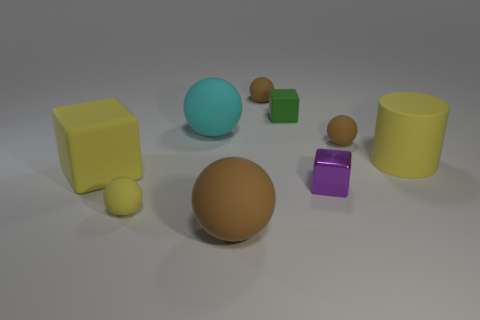Are there any other cyan balls made of the same material as the big cyan sphere?
Provide a short and direct response. No. What material is the big thing that is to the left of the big cyan sphere?
Ensure brevity in your answer.  Rubber. Does the small sphere in front of the large yellow matte cylinder have the same color as the cube behind the big cyan sphere?
Keep it short and to the point. No. The cube that is the same size as the cylinder is what color?
Your answer should be very brief. Yellow. How many other things are there of the same shape as the purple object?
Provide a succinct answer. 2. What size is the yellow rubber object on the right side of the big cyan rubber thing?
Ensure brevity in your answer.  Large. There is a small rubber thing on the left side of the big cyan rubber thing; what number of tiny yellow spheres are behind it?
Your answer should be compact. 0. How many other objects are there of the same size as the purple metal block?
Offer a terse response. 4. Is the color of the tiny matte block the same as the big cylinder?
Offer a very short reply. No. There is a yellow object that is right of the large brown matte ball; is it the same shape as the tiny green object?
Your answer should be compact. No. 